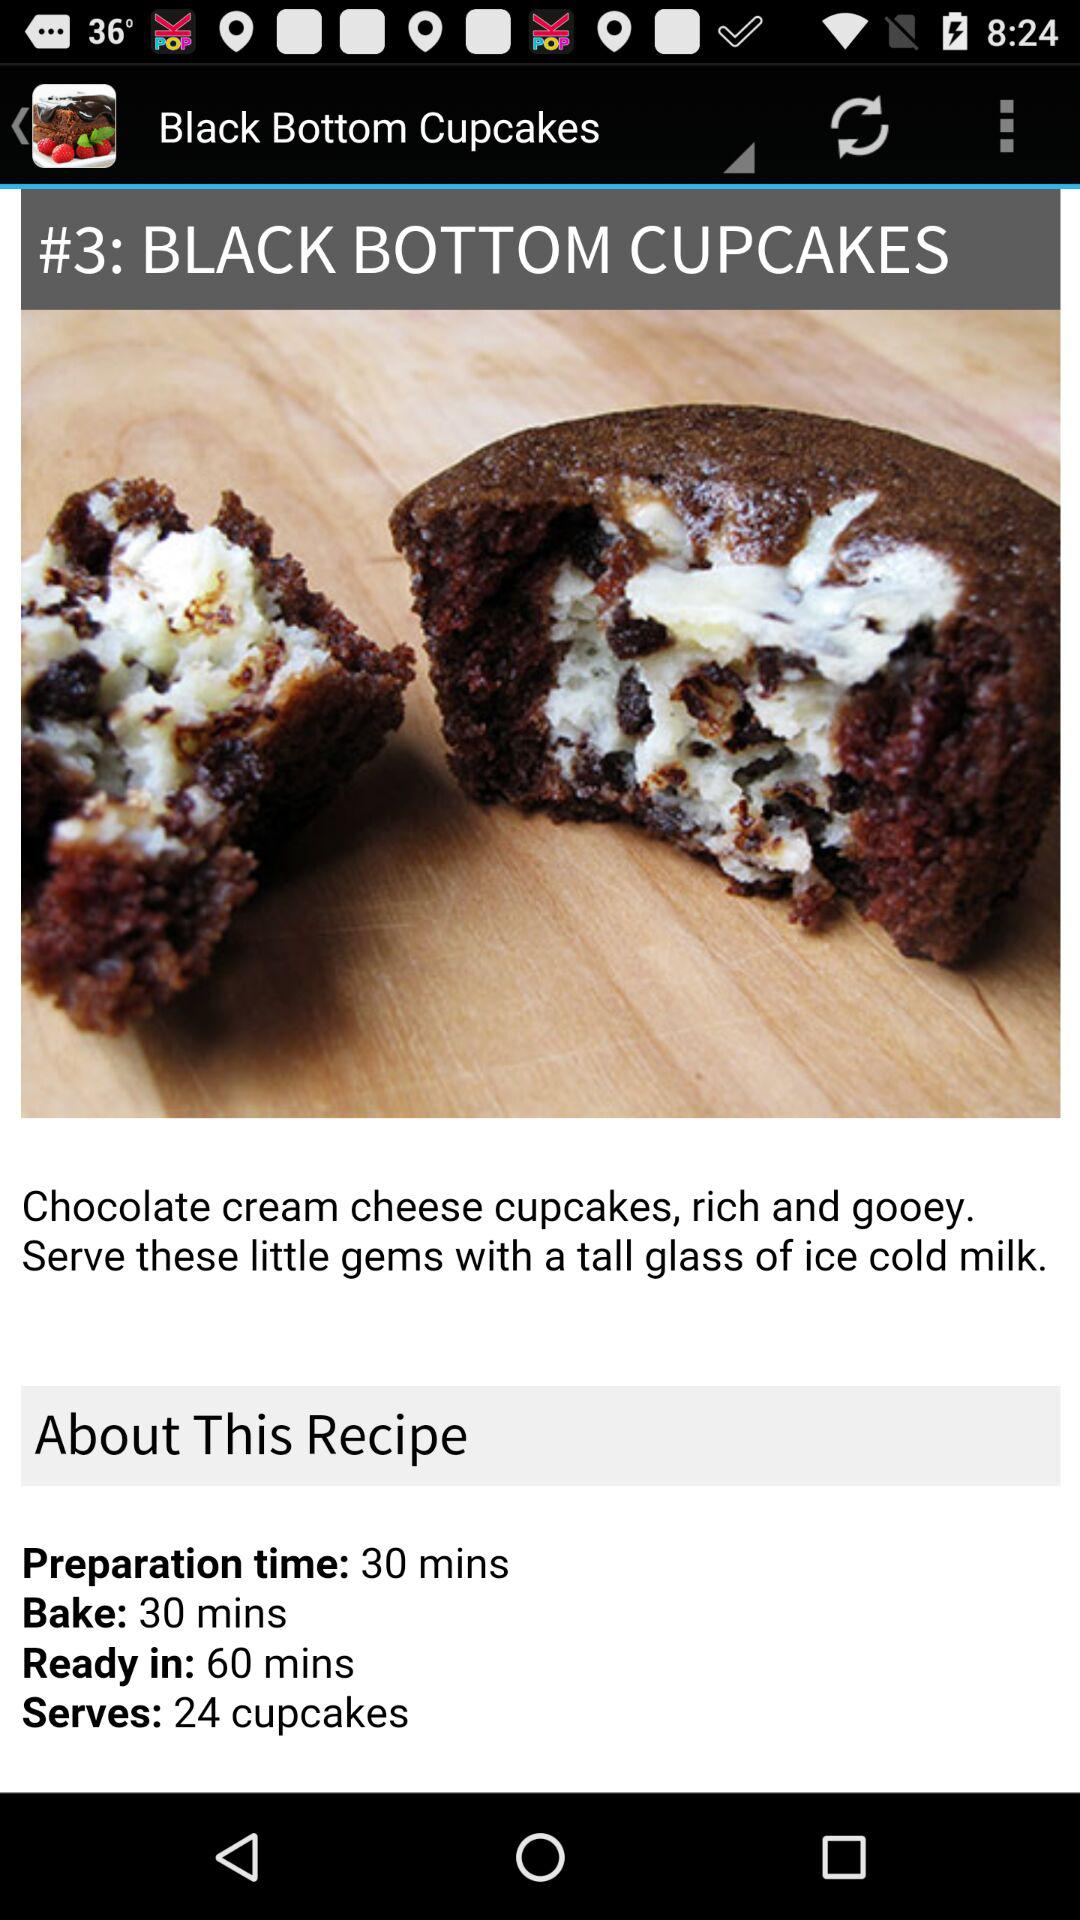How much time does it take for "Black Bottom Cupcakes" to be ready? It takes 60 minutes. 